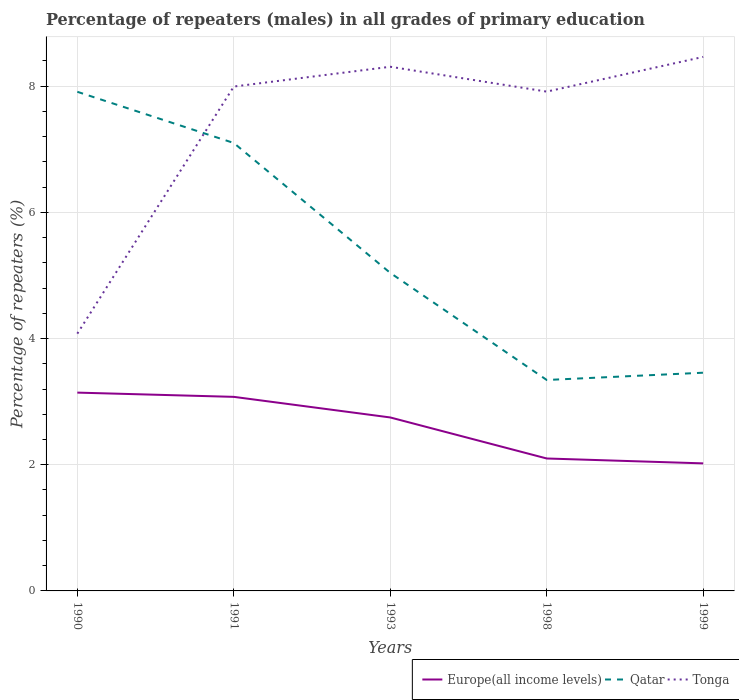How many different coloured lines are there?
Make the answer very short. 3. Does the line corresponding to Europe(all income levels) intersect with the line corresponding to Tonga?
Offer a very short reply. No. Is the number of lines equal to the number of legend labels?
Make the answer very short. Yes. Across all years, what is the maximum percentage of repeaters (males) in Europe(all income levels)?
Offer a very short reply. 2.02. In which year was the percentage of repeaters (males) in Qatar maximum?
Keep it short and to the point. 1998. What is the total percentage of repeaters (males) in Europe(all income levels) in the graph?
Offer a very short reply. 0.39. What is the difference between the highest and the second highest percentage of repeaters (males) in Tonga?
Keep it short and to the point. 4.39. How many years are there in the graph?
Your response must be concise. 5. Are the values on the major ticks of Y-axis written in scientific E-notation?
Your answer should be very brief. No. Does the graph contain any zero values?
Give a very brief answer. No. How many legend labels are there?
Provide a short and direct response. 3. What is the title of the graph?
Offer a terse response. Percentage of repeaters (males) in all grades of primary education. Does "Botswana" appear as one of the legend labels in the graph?
Provide a short and direct response. No. What is the label or title of the X-axis?
Provide a short and direct response. Years. What is the label or title of the Y-axis?
Keep it short and to the point. Percentage of repeaters (%). What is the Percentage of repeaters (%) of Europe(all income levels) in 1990?
Offer a very short reply. 3.14. What is the Percentage of repeaters (%) of Qatar in 1990?
Offer a terse response. 7.91. What is the Percentage of repeaters (%) of Tonga in 1990?
Give a very brief answer. 4.08. What is the Percentage of repeaters (%) of Europe(all income levels) in 1991?
Give a very brief answer. 3.08. What is the Percentage of repeaters (%) in Qatar in 1991?
Make the answer very short. 7.1. What is the Percentage of repeaters (%) of Tonga in 1991?
Provide a short and direct response. 7.99. What is the Percentage of repeaters (%) of Europe(all income levels) in 1993?
Your answer should be very brief. 2.75. What is the Percentage of repeaters (%) in Qatar in 1993?
Your answer should be compact. 5.04. What is the Percentage of repeaters (%) of Tonga in 1993?
Ensure brevity in your answer.  8.31. What is the Percentage of repeaters (%) of Europe(all income levels) in 1998?
Give a very brief answer. 2.1. What is the Percentage of repeaters (%) of Qatar in 1998?
Your answer should be very brief. 3.34. What is the Percentage of repeaters (%) in Tonga in 1998?
Your answer should be compact. 7.91. What is the Percentage of repeaters (%) of Europe(all income levels) in 1999?
Give a very brief answer. 2.02. What is the Percentage of repeaters (%) in Qatar in 1999?
Make the answer very short. 3.46. What is the Percentage of repeaters (%) in Tonga in 1999?
Offer a very short reply. 8.46. Across all years, what is the maximum Percentage of repeaters (%) of Europe(all income levels)?
Make the answer very short. 3.14. Across all years, what is the maximum Percentage of repeaters (%) of Qatar?
Offer a terse response. 7.91. Across all years, what is the maximum Percentage of repeaters (%) in Tonga?
Your response must be concise. 8.46. Across all years, what is the minimum Percentage of repeaters (%) in Europe(all income levels)?
Offer a terse response. 2.02. Across all years, what is the minimum Percentage of repeaters (%) in Qatar?
Offer a very short reply. 3.34. Across all years, what is the minimum Percentage of repeaters (%) in Tonga?
Ensure brevity in your answer.  4.08. What is the total Percentage of repeaters (%) of Europe(all income levels) in the graph?
Offer a terse response. 13.09. What is the total Percentage of repeaters (%) in Qatar in the graph?
Make the answer very short. 26.86. What is the total Percentage of repeaters (%) in Tonga in the graph?
Your answer should be very brief. 36.76. What is the difference between the Percentage of repeaters (%) of Europe(all income levels) in 1990 and that in 1991?
Your answer should be compact. 0.07. What is the difference between the Percentage of repeaters (%) of Qatar in 1990 and that in 1991?
Keep it short and to the point. 0.81. What is the difference between the Percentage of repeaters (%) in Tonga in 1990 and that in 1991?
Provide a succinct answer. -3.92. What is the difference between the Percentage of repeaters (%) of Europe(all income levels) in 1990 and that in 1993?
Make the answer very short. 0.39. What is the difference between the Percentage of repeaters (%) in Qatar in 1990 and that in 1993?
Provide a short and direct response. 2.87. What is the difference between the Percentage of repeaters (%) of Tonga in 1990 and that in 1993?
Make the answer very short. -4.23. What is the difference between the Percentage of repeaters (%) in Europe(all income levels) in 1990 and that in 1998?
Offer a terse response. 1.04. What is the difference between the Percentage of repeaters (%) of Qatar in 1990 and that in 1998?
Your response must be concise. 4.57. What is the difference between the Percentage of repeaters (%) in Tonga in 1990 and that in 1998?
Your answer should be very brief. -3.84. What is the difference between the Percentage of repeaters (%) in Europe(all income levels) in 1990 and that in 1999?
Offer a very short reply. 1.12. What is the difference between the Percentage of repeaters (%) of Qatar in 1990 and that in 1999?
Ensure brevity in your answer.  4.45. What is the difference between the Percentage of repeaters (%) of Tonga in 1990 and that in 1999?
Offer a terse response. -4.39. What is the difference between the Percentage of repeaters (%) of Europe(all income levels) in 1991 and that in 1993?
Ensure brevity in your answer.  0.33. What is the difference between the Percentage of repeaters (%) in Qatar in 1991 and that in 1993?
Provide a short and direct response. 2.06. What is the difference between the Percentage of repeaters (%) in Tonga in 1991 and that in 1993?
Offer a very short reply. -0.31. What is the difference between the Percentage of repeaters (%) in Europe(all income levels) in 1991 and that in 1998?
Offer a terse response. 0.98. What is the difference between the Percentage of repeaters (%) in Qatar in 1991 and that in 1998?
Your response must be concise. 3.76. What is the difference between the Percentage of repeaters (%) of Tonga in 1991 and that in 1998?
Offer a very short reply. 0.08. What is the difference between the Percentage of repeaters (%) in Europe(all income levels) in 1991 and that in 1999?
Give a very brief answer. 1.05. What is the difference between the Percentage of repeaters (%) of Qatar in 1991 and that in 1999?
Make the answer very short. 3.64. What is the difference between the Percentage of repeaters (%) in Tonga in 1991 and that in 1999?
Ensure brevity in your answer.  -0.47. What is the difference between the Percentage of repeaters (%) in Europe(all income levels) in 1993 and that in 1998?
Give a very brief answer. 0.65. What is the difference between the Percentage of repeaters (%) of Qatar in 1993 and that in 1998?
Make the answer very short. 1.7. What is the difference between the Percentage of repeaters (%) in Tonga in 1993 and that in 1998?
Provide a succinct answer. 0.39. What is the difference between the Percentage of repeaters (%) of Europe(all income levels) in 1993 and that in 1999?
Your answer should be very brief. 0.73. What is the difference between the Percentage of repeaters (%) in Qatar in 1993 and that in 1999?
Make the answer very short. 1.58. What is the difference between the Percentage of repeaters (%) of Tonga in 1993 and that in 1999?
Keep it short and to the point. -0.16. What is the difference between the Percentage of repeaters (%) of Europe(all income levels) in 1998 and that in 1999?
Your answer should be very brief. 0.08. What is the difference between the Percentage of repeaters (%) in Qatar in 1998 and that in 1999?
Offer a very short reply. -0.12. What is the difference between the Percentage of repeaters (%) of Tonga in 1998 and that in 1999?
Your answer should be very brief. -0.55. What is the difference between the Percentage of repeaters (%) of Europe(all income levels) in 1990 and the Percentage of repeaters (%) of Qatar in 1991?
Offer a terse response. -3.96. What is the difference between the Percentage of repeaters (%) in Europe(all income levels) in 1990 and the Percentage of repeaters (%) in Tonga in 1991?
Your answer should be compact. -4.85. What is the difference between the Percentage of repeaters (%) of Qatar in 1990 and the Percentage of repeaters (%) of Tonga in 1991?
Your response must be concise. -0.08. What is the difference between the Percentage of repeaters (%) of Europe(all income levels) in 1990 and the Percentage of repeaters (%) of Qatar in 1993?
Make the answer very short. -1.9. What is the difference between the Percentage of repeaters (%) in Europe(all income levels) in 1990 and the Percentage of repeaters (%) in Tonga in 1993?
Give a very brief answer. -5.17. What is the difference between the Percentage of repeaters (%) in Qatar in 1990 and the Percentage of repeaters (%) in Tonga in 1993?
Offer a terse response. -0.4. What is the difference between the Percentage of repeaters (%) of Europe(all income levels) in 1990 and the Percentage of repeaters (%) of Qatar in 1998?
Keep it short and to the point. -0.2. What is the difference between the Percentage of repeaters (%) in Europe(all income levels) in 1990 and the Percentage of repeaters (%) in Tonga in 1998?
Your answer should be compact. -4.77. What is the difference between the Percentage of repeaters (%) in Qatar in 1990 and the Percentage of repeaters (%) in Tonga in 1998?
Your answer should be compact. -0. What is the difference between the Percentage of repeaters (%) of Europe(all income levels) in 1990 and the Percentage of repeaters (%) of Qatar in 1999?
Offer a terse response. -0.32. What is the difference between the Percentage of repeaters (%) in Europe(all income levels) in 1990 and the Percentage of repeaters (%) in Tonga in 1999?
Provide a succinct answer. -5.32. What is the difference between the Percentage of repeaters (%) of Qatar in 1990 and the Percentage of repeaters (%) of Tonga in 1999?
Your response must be concise. -0.55. What is the difference between the Percentage of repeaters (%) of Europe(all income levels) in 1991 and the Percentage of repeaters (%) of Qatar in 1993?
Offer a terse response. -1.96. What is the difference between the Percentage of repeaters (%) in Europe(all income levels) in 1991 and the Percentage of repeaters (%) in Tonga in 1993?
Keep it short and to the point. -5.23. What is the difference between the Percentage of repeaters (%) in Qatar in 1991 and the Percentage of repeaters (%) in Tonga in 1993?
Give a very brief answer. -1.21. What is the difference between the Percentage of repeaters (%) of Europe(all income levels) in 1991 and the Percentage of repeaters (%) of Qatar in 1998?
Your answer should be compact. -0.27. What is the difference between the Percentage of repeaters (%) of Europe(all income levels) in 1991 and the Percentage of repeaters (%) of Tonga in 1998?
Offer a very short reply. -4.84. What is the difference between the Percentage of repeaters (%) in Qatar in 1991 and the Percentage of repeaters (%) in Tonga in 1998?
Ensure brevity in your answer.  -0.81. What is the difference between the Percentage of repeaters (%) in Europe(all income levels) in 1991 and the Percentage of repeaters (%) in Qatar in 1999?
Offer a terse response. -0.38. What is the difference between the Percentage of repeaters (%) in Europe(all income levels) in 1991 and the Percentage of repeaters (%) in Tonga in 1999?
Ensure brevity in your answer.  -5.39. What is the difference between the Percentage of repeaters (%) in Qatar in 1991 and the Percentage of repeaters (%) in Tonga in 1999?
Your answer should be compact. -1.36. What is the difference between the Percentage of repeaters (%) in Europe(all income levels) in 1993 and the Percentage of repeaters (%) in Qatar in 1998?
Offer a terse response. -0.59. What is the difference between the Percentage of repeaters (%) in Europe(all income levels) in 1993 and the Percentage of repeaters (%) in Tonga in 1998?
Your answer should be compact. -5.16. What is the difference between the Percentage of repeaters (%) in Qatar in 1993 and the Percentage of repeaters (%) in Tonga in 1998?
Provide a succinct answer. -2.87. What is the difference between the Percentage of repeaters (%) of Europe(all income levels) in 1993 and the Percentage of repeaters (%) of Qatar in 1999?
Your response must be concise. -0.71. What is the difference between the Percentage of repeaters (%) of Europe(all income levels) in 1993 and the Percentage of repeaters (%) of Tonga in 1999?
Make the answer very short. -5.72. What is the difference between the Percentage of repeaters (%) in Qatar in 1993 and the Percentage of repeaters (%) in Tonga in 1999?
Provide a short and direct response. -3.42. What is the difference between the Percentage of repeaters (%) of Europe(all income levels) in 1998 and the Percentage of repeaters (%) of Qatar in 1999?
Your response must be concise. -1.36. What is the difference between the Percentage of repeaters (%) in Europe(all income levels) in 1998 and the Percentage of repeaters (%) in Tonga in 1999?
Offer a terse response. -6.37. What is the difference between the Percentage of repeaters (%) in Qatar in 1998 and the Percentage of repeaters (%) in Tonga in 1999?
Provide a succinct answer. -5.12. What is the average Percentage of repeaters (%) of Europe(all income levels) per year?
Make the answer very short. 2.62. What is the average Percentage of repeaters (%) in Qatar per year?
Offer a terse response. 5.37. What is the average Percentage of repeaters (%) in Tonga per year?
Your answer should be very brief. 7.35. In the year 1990, what is the difference between the Percentage of repeaters (%) of Europe(all income levels) and Percentage of repeaters (%) of Qatar?
Provide a succinct answer. -4.77. In the year 1990, what is the difference between the Percentage of repeaters (%) of Europe(all income levels) and Percentage of repeaters (%) of Tonga?
Keep it short and to the point. -0.93. In the year 1990, what is the difference between the Percentage of repeaters (%) in Qatar and Percentage of repeaters (%) in Tonga?
Ensure brevity in your answer.  3.83. In the year 1991, what is the difference between the Percentage of repeaters (%) of Europe(all income levels) and Percentage of repeaters (%) of Qatar?
Offer a terse response. -4.02. In the year 1991, what is the difference between the Percentage of repeaters (%) in Europe(all income levels) and Percentage of repeaters (%) in Tonga?
Ensure brevity in your answer.  -4.92. In the year 1991, what is the difference between the Percentage of repeaters (%) of Qatar and Percentage of repeaters (%) of Tonga?
Provide a short and direct response. -0.89. In the year 1993, what is the difference between the Percentage of repeaters (%) in Europe(all income levels) and Percentage of repeaters (%) in Qatar?
Make the answer very short. -2.29. In the year 1993, what is the difference between the Percentage of repeaters (%) in Europe(all income levels) and Percentage of repeaters (%) in Tonga?
Your response must be concise. -5.56. In the year 1993, what is the difference between the Percentage of repeaters (%) in Qatar and Percentage of repeaters (%) in Tonga?
Your answer should be very brief. -3.27. In the year 1998, what is the difference between the Percentage of repeaters (%) of Europe(all income levels) and Percentage of repeaters (%) of Qatar?
Give a very brief answer. -1.24. In the year 1998, what is the difference between the Percentage of repeaters (%) of Europe(all income levels) and Percentage of repeaters (%) of Tonga?
Provide a succinct answer. -5.82. In the year 1998, what is the difference between the Percentage of repeaters (%) in Qatar and Percentage of repeaters (%) in Tonga?
Give a very brief answer. -4.57. In the year 1999, what is the difference between the Percentage of repeaters (%) in Europe(all income levels) and Percentage of repeaters (%) in Qatar?
Your response must be concise. -1.44. In the year 1999, what is the difference between the Percentage of repeaters (%) in Europe(all income levels) and Percentage of repeaters (%) in Tonga?
Provide a short and direct response. -6.44. In the year 1999, what is the difference between the Percentage of repeaters (%) of Qatar and Percentage of repeaters (%) of Tonga?
Your answer should be compact. -5.01. What is the ratio of the Percentage of repeaters (%) of Europe(all income levels) in 1990 to that in 1991?
Keep it short and to the point. 1.02. What is the ratio of the Percentage of repeaters (%) in Qatar in 1990 to that in 1991?
Provide a short and direct response. 1.11. What is the ratio of the Percentage of repeaters (%) in Tonga in 1990 to that in 1991?
Make the answer very short. 0.51. What is the ratio of the Percentage of repeaters (%) of Europe(all income levels) in 1990 to that in 1993?
Your answer should be very brief. 1.14. What is the ratio of the Percentage of repeaters (%) in Qatar in 1990 to that in 1993?
Provide a short and direct response. 1.57. What is the ratio of the Percentage of repeaters (%) of Tonga in 1990 to that in 1993?
Provide a succinct answer. 0.49. What is the ratio of the Percentage of repeaters (%) of Europe(all income levels) in 1990 to that in 1998?
Provide a short and direct response. 1.5. What is the ratio of the Percentage of repeaters (%) of Qatar in 1990 to that in 1998?
Provide a short and direct response. 2.37. What is the ratio of the Percentage of repeaters (%) of Tonga in 1990 to that in 1998?
Ensure brevity in your answer.  0.52. What is the ratio of the Percentage of repeaters (%) of Europe(all income levels) in 1990 to that in 1999?
Your answer should be compact. 1.55. What is the ratio of the Percentage of repeaters (%) of Qatar in 1990 to that in 1999?
Keep it short and to the point. 2.29. What is the ratio of the Percentage of repeaters (%) of Tonga in 1990 to that in 1999?
Provide a short and direct response. 0.48. What is the ratio of the Percentage of repeaters (%) in Europe(all income levels) in 1991 to that in 1993?
Offer a very short reply. 1.12. What is the ratio of the Percentage of repeaters (%) in Qatar in 1991 to that in 1993?
Provide a succinct answer. 1.41. What is the ratio of the Percentage of repeaters (%) of Tonga in 1991 to that in 1993?
Your answer should be very brief. 0.96. What is the ratio of the Percentage of repeaters (%) of Europe(all income levels) in 1991 to that in 1998?
Make the answer very short. 1.47. What is the ratio of the Percentage of repeaters (%) in Qatar in 1991 to that in 1998?
Keep it short and to the point. 2.12. What is the ratio of the Percentage of repeaters (%) of Europe(all income levels) in 1991 to that in 1999?
Your answer should be very brief. 1.52. What is the ratio of the Percentage of repeaters (%) in Qatar in 1991 to that in 1999?
Ensure brevity in your answer.  2.05. What is the ratio of the Percentage of repeaters (%) of Tonga in 1991 to that in 1999?
Make the answer very short. 0.94. What is the ratio of the Percentage of repeaters (%) of Europe(all income levels) in 1993 to that in 1998?
Make the answer very short. 1.31. What is the ratio of the Percentage of repeaters (%) of Qatar in 1993 to that in 1998?
Your answer should be compact. 1.51. What is the ratio of the Percentage of repeaters (%) of Tonga in 1993 to that in 1998?
Offer a very short reply. 1.05. What is the ratio of the Percentage of repeaters (%) of Europe(all income levels) in 1993 to that in 1999?
Provide a succinct answer. 1.36. What is the ratio of the Percentage of repeaters (%) in Qatar in 1993 to that in 1999?
Offer a terse response. 1.46. What is the ratio of the Percentage of repeaters (%) of Tonga in 1993 to that in 1999?
Give a very brief answer. 0.98. What is the ratio of the Percentage of repeaters (%) of Europe(all income levels) in 1998 to that in 1999?
Offer a very short reply. 1.04. What is the ratio of the Percentage of repeaters (%) in Qatar in 1998 to that in 1999?
Offer a terse response. 0.97. What is the ratio of the Percentage of repeaters (%) of Tonga in 1998 to that in 1999?
Ensure brevity in your answer.  0.94. What is the difference between the highest and the second highest Percentage of repeaters (%) of Europe(all income levels)?
Your answer should be compact. 0.07. What is the difference between the highest and the second highest Percentage of repeaters (%) of Qatar?
Keep it short and to the point. 0.81. What is the difference between the highest and the second highest Percentage of repeaters (%) of Tonga?
Your answer should be compact. 0.16. What is the difference between the highest and the lowest Percentage of repeaters (%) in Europe(all income levels)?
Give a very brief answer. 1.12. What is the difference between the highest and the lowest Percentage of repeaters (%) in Qatar?
Your answer should be very brief. 4.57. What is the difference between the highest and the lowest Percentage of repeaters (%) of Tonga?
Offer a terse response. 4.39. 